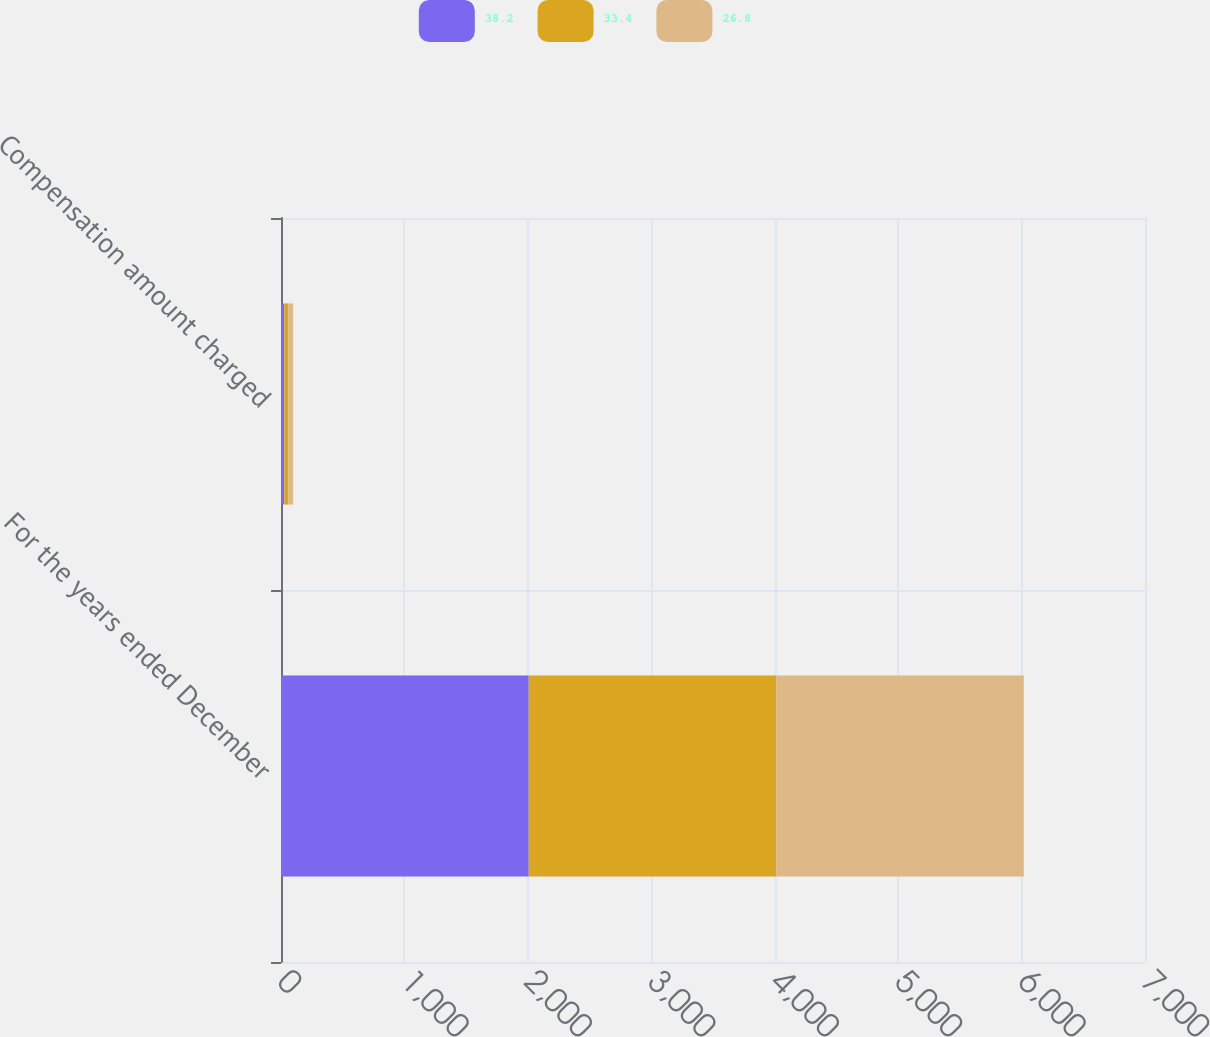<chart> <loc_0><loc_0><loc_500><loc_500><stacked_bar_chart><ecel><fcel>For the years ended December<fcel>Compensation amount charged<nl><fcel>38.2<fcel>2007<fcel>26.8<nl><fcel>33.4<fcel>2006<fcel>33.4<nl><fcel>26.8<fcel>2005<fcel>38.2<nl></chart> 